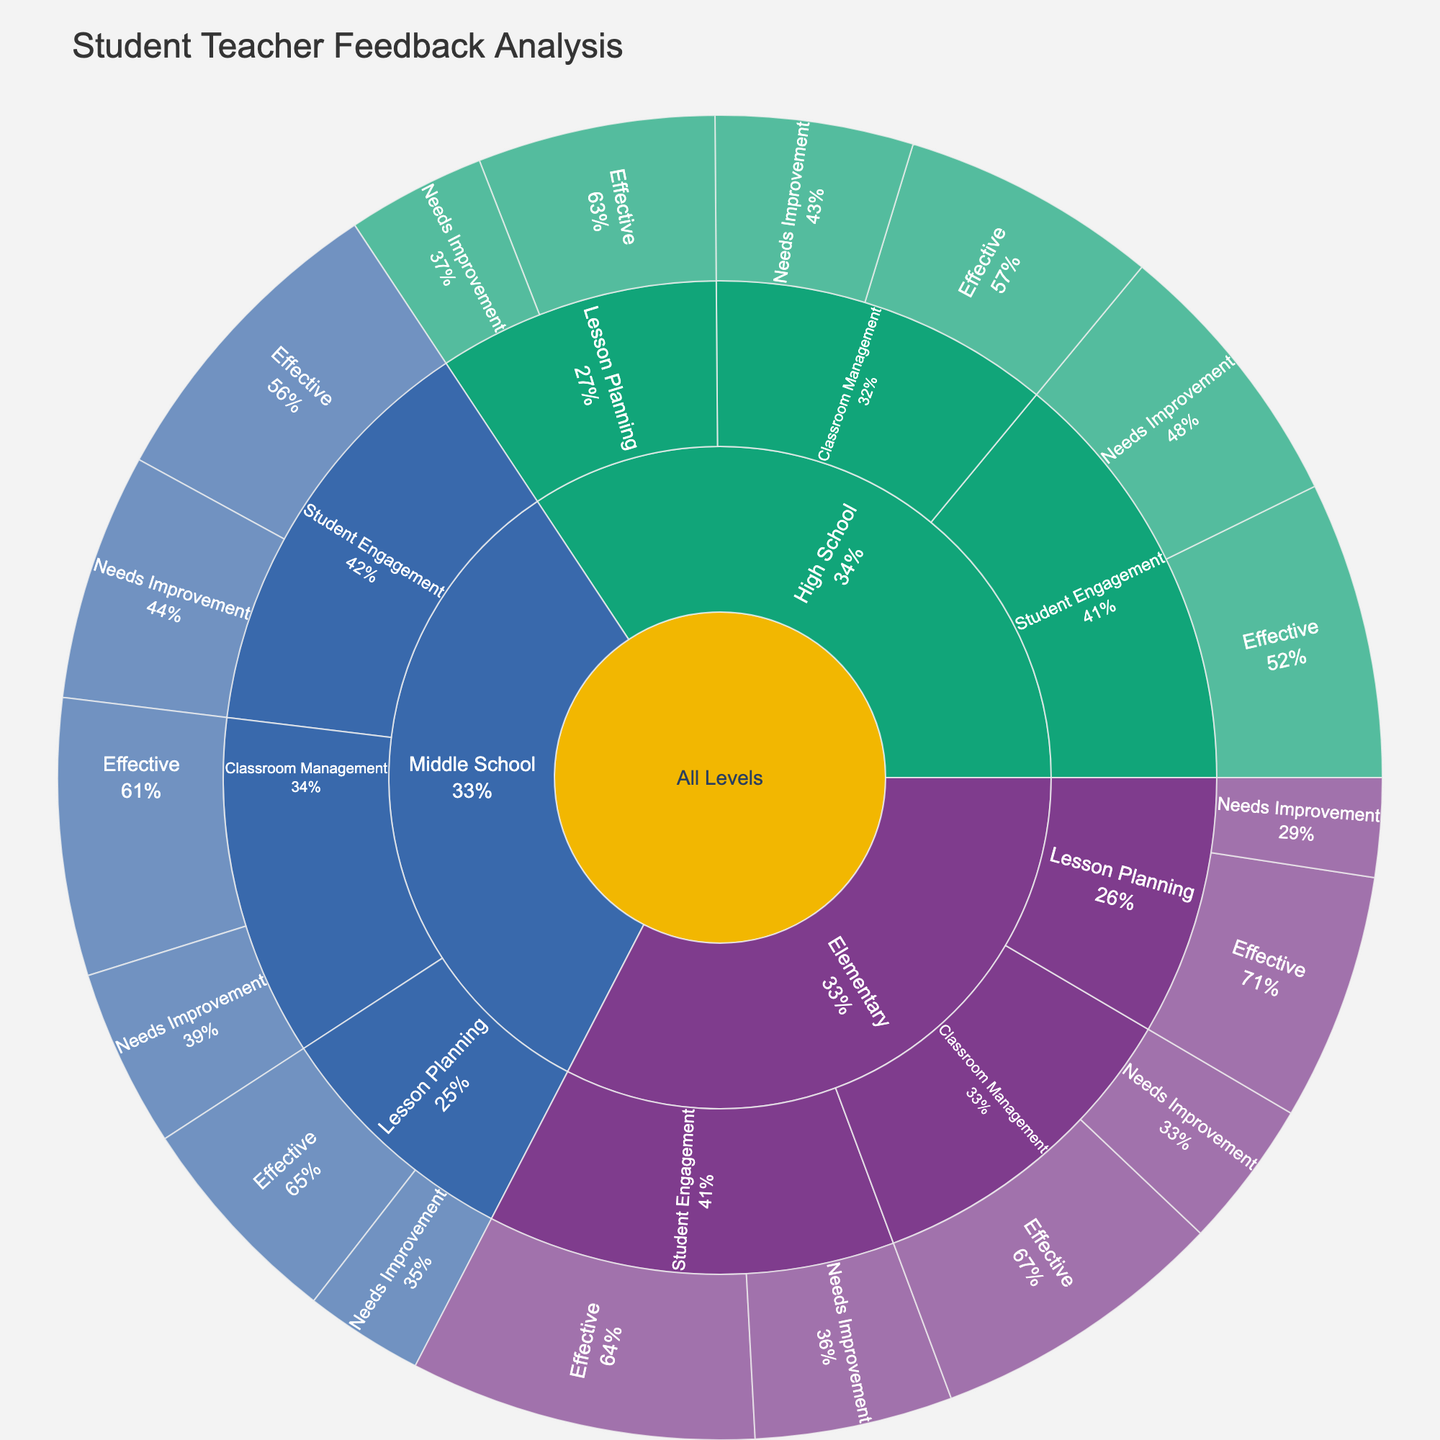what's the title of the plot? The title is often prominently displayed at the top of the plot. It provides a summary of what the plot represents. In this case, the title is stated in the code used to generate the plot.
Answer: Student Teacher Feedback Analysis What is the total number of feedback points for Elementary? To find the total for Elementary, sum the values for each subcategory and aspect under Elementary. (30+15+25+10+35+20) = 135
Answer: 135 Which teaching aspect in Elementary received the highest number of 'Effective' feedback? Look for the subcategory under Elementary that has the highest numeric value labeled 'Effective'. Student Engagement (35) is the highest.
Answer: Student Engagement How does the number of 'Effective' feedback for Classroom Management compare between Elementary and Middle School? Compare the values of 'Effective' feedback for Classroom Management in both categories: Elementary (30) and Middle School (28).
Answer: Elementary received slightly more effective feedback What's the difference in 'Needs Improvement' feedback between High School Student Engagement and Middle School Student Engagement? Find the 'Needs Improvement' values for Student Engagement in both High School (28) and Middle School (25) and calculate the difference. 28 - 25 = 3
Answer: 3 What percentage of the total feedback for Middle School is 'Effective' Student Engagement feedback? To find the percentage, sum all feedback values for Middle School and divide the 'Effective' Student Engagement feedback by this sum, then multiply by 100 to get the percentage. (28+18+22+12+32+25) = 137. (32/137) * 100 ≈ 23.4%
Answer: ≈ 23.4% Which grade level has the least 'Needs Improvement' feedback for Lesson Planning? Compare the 'Needs Improvement' feedback values for Lesson Planning across all categories: Elementary (10), Middle School (12), and High School (14). Elementary has the least.
Answer: Elementary What is the overall distribution of 'Effective' feedback across all teaching aspects in High School? Sum all 'Effective' feedback values for High School and analyze the distribution among Classroom Management, Lesson Planning, and Student Engagement. (26+24+30) = 80, Classroom Management: 26/80, Lesson Planning: 24/80, Student Engagement: 30/80
Answer: Classroom Management: 32.5%, Lesson Planning: 30%, Student Engagement: 37.5% What is the sum of 'Needs Improvement' feedback across all grade levels? Sum the 'Needs Improvement' feedback values across all categories and aspects. (15+10+20+18+12+25+20+14+28) = 162
Answer: 162 Which teaching aspect has the largest difference in 'Effective' feedback between Elementary and High School? Calculate the difference in 'Effective' feedback between Elementary and High School for all aspects: Classroom Management (30-26), Lesson Planning (25-24), Student Engagement (35-30). Classroom Management has the largest difference (4).
Answer: Classroom Management 